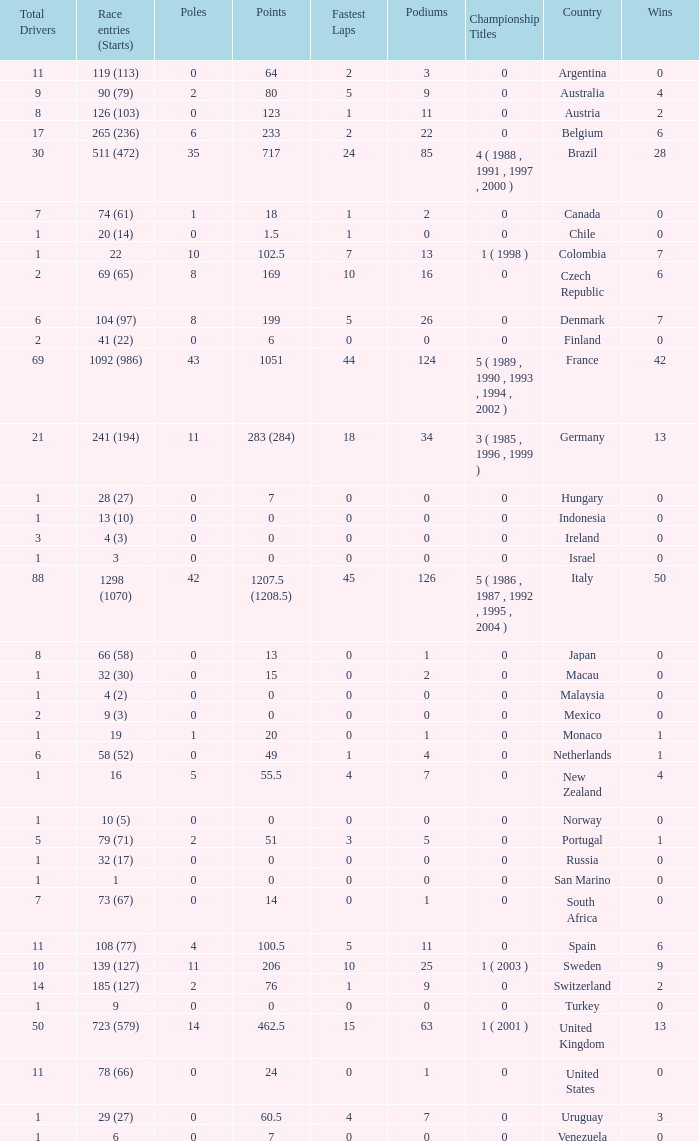How many fastest laps for the nation with 32 (30) entries and starts and fewer than 2 podiums? None. 